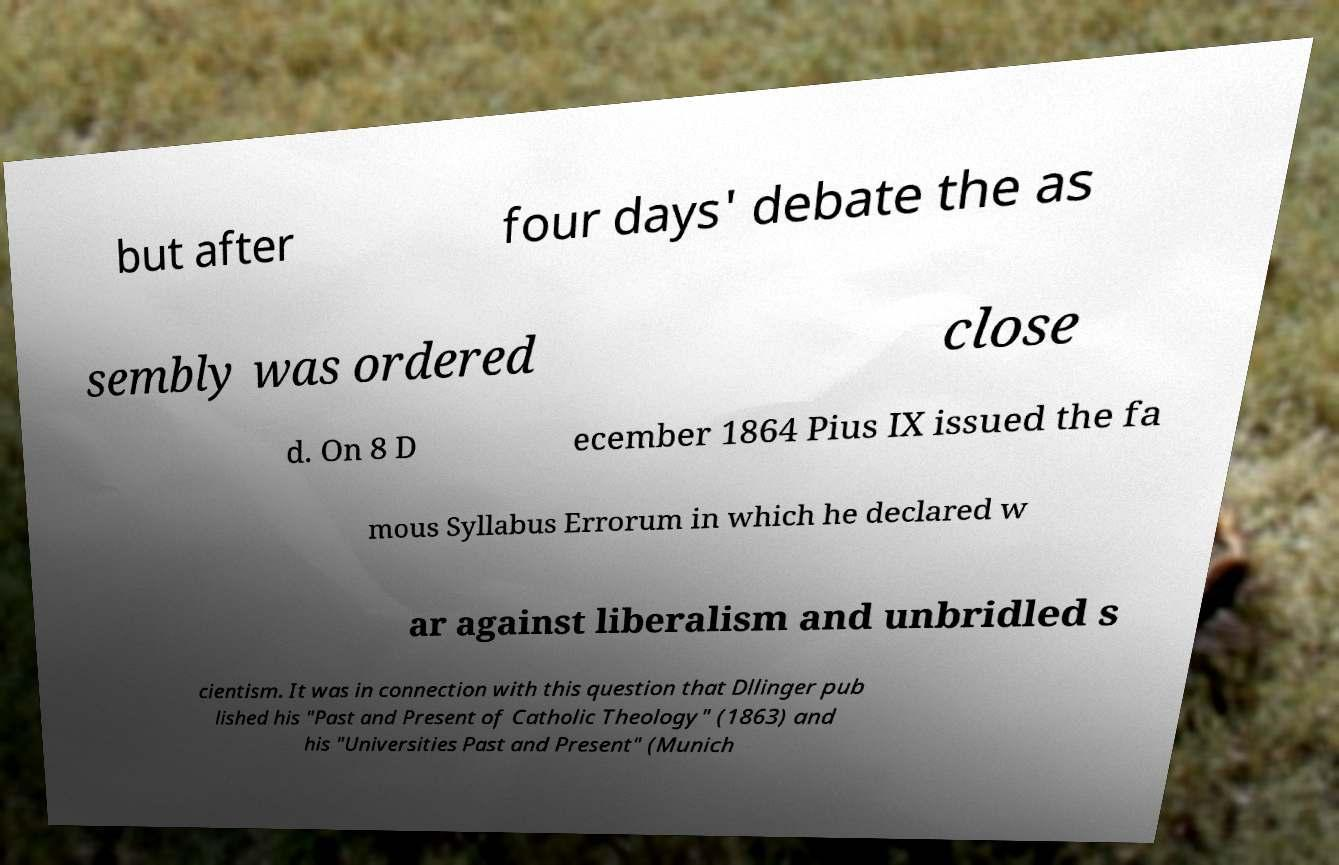Please read and relay the text visible in this image. What does it say? but after four days' debate the as sembly was ordered close d. On 8 D ecember 1864 Pius IX issued the fa mous Syllabus Errorum in which he declared w ar against liberalism and unbridled s cientism. It was in connection with this question that Dllinger pub lished his "Past and Present of Catholic Theology" (1863) and his "Universities Past and Present" (Munich 